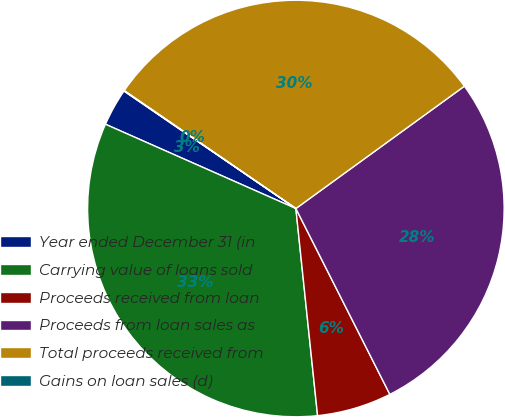Convert chart to OTSL. <chart><loc_0><loc_0><loc_500><loc_500><pie_chart><fcel>Year ended December 31 (in<fcel>Carrying value of loans sold<fcel>Proceeds received from loan<fcel>Proceeds from loan sales as<fcel>Total proceeds received from<fcel>Gains on loan sales (d)<nl><fcel>2.91%<fcel>33.29%<fcel>5.79%<fcel>27.54%<fcel>30.42%<fcel>0.04%<nl></chart> 